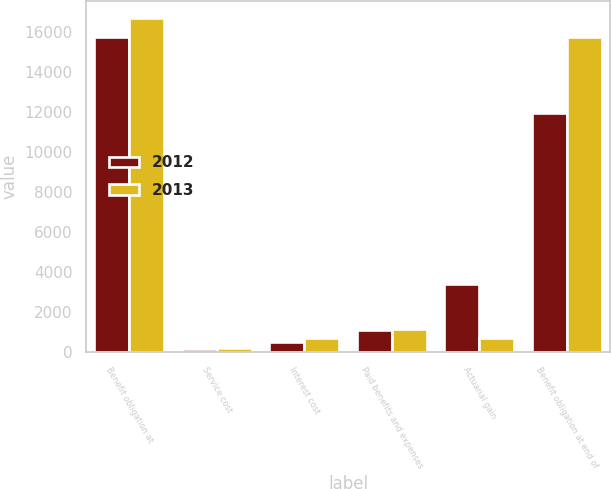<chart> <loc_0><loc_0><loc_500><loc_500><stacked_bar_chart><ecel><fcel>Benefit obligation at<fcel>Service cost<fcel>Interest cost<fcel>Paid benefits and expenses<fcel>Actuarial gain<fcel>Benefit obligation at end of<nl><fcel>2012<fcel>15713<fcel>160<fcel>511<fcel>1080<fcel>3374<fcel>11930<nl><fcel>2013<fcel>16698<fcel>179<fcel>677<fcel>1141<fcel>700<fcel>15713<nl></chart> 